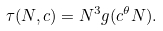<formula> <loc_0><loc_0><loc_500><loc_500>\tau ( N , c ) = N ^ { 3 } g ( c ^ { \theta } N ) .</formula> 